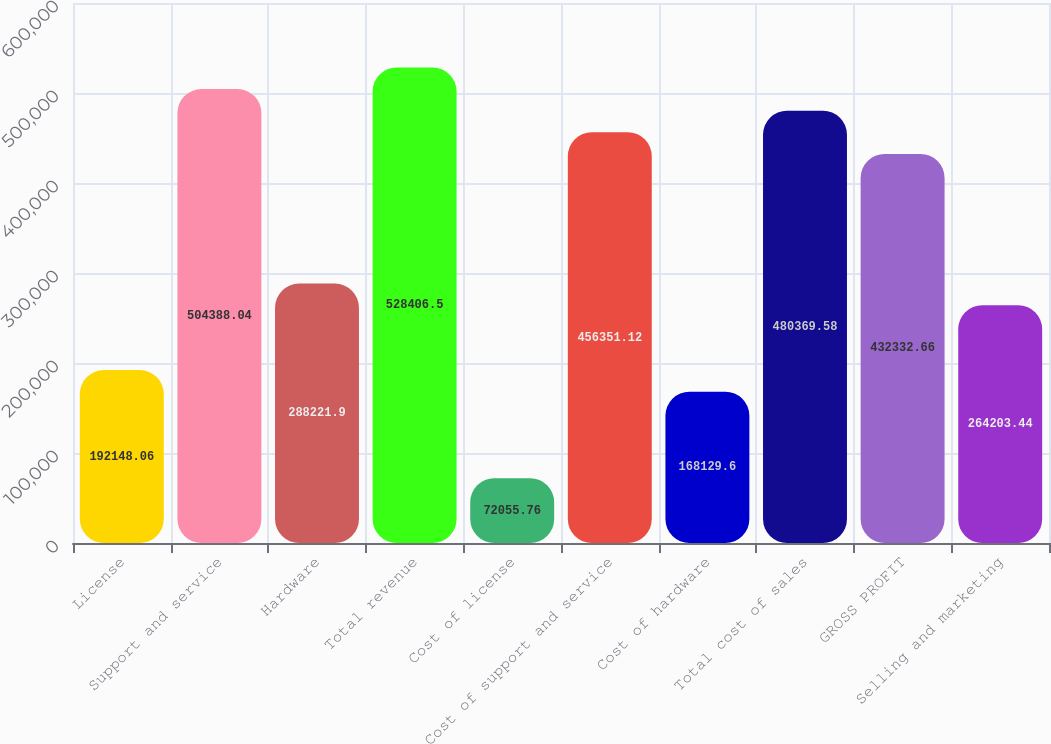Convert chart to OTSL. <chart><loc_0><loc_0><loc_500><loc_500><bar_chart><fcel>License<fcel>Support and service<fcel>Hardware<fcel>Total revenue<fcel>Cost of license<fcel>Cost of support and service<fcel>Cost of hardware<fcel>Total cost of sales<fcel>GROSS PROFIT<fcel>Selling and marketing<nl><fcel>192148<fcel>504388<fcel>288222<fcel>528406<fcel>72055.8<fcel>456351<fcel>168130<fcel>480370<fcel>432333<fcel>264203<nl></chart> 